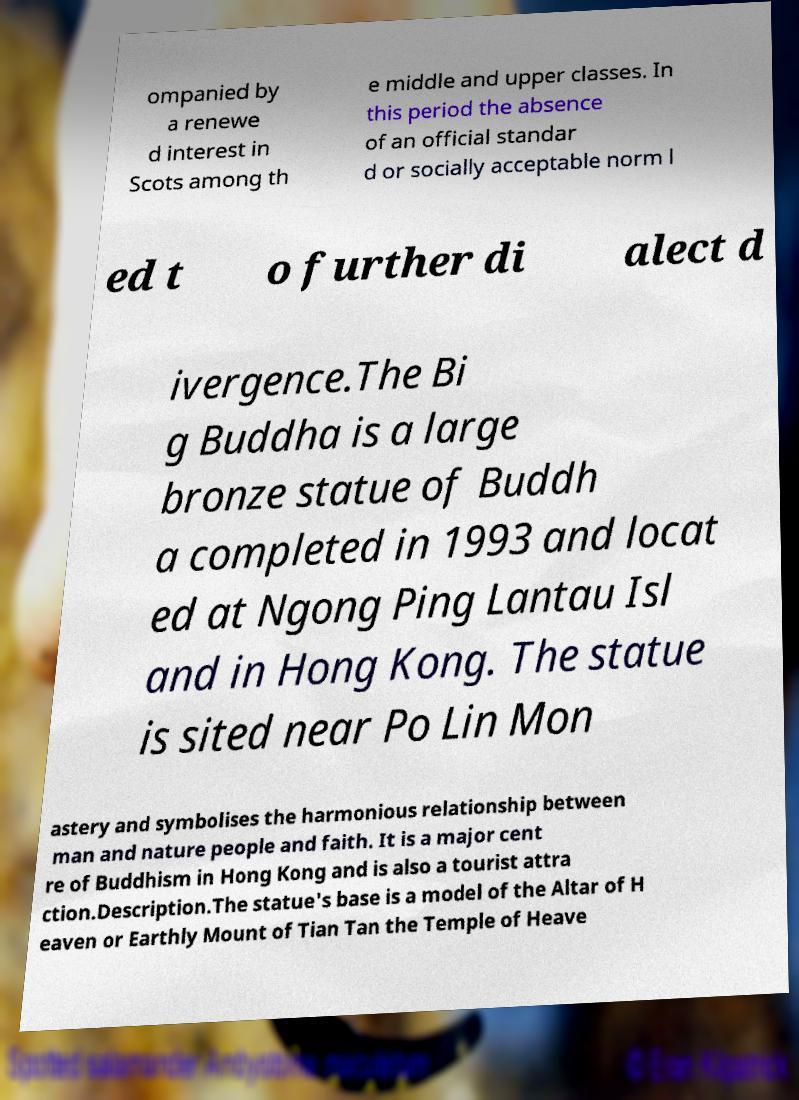Can you read and provide the text displayed in the image?This photo seems to have some interesting text. Can you extract and type it out for me? ompanied by a renewe d interest in Scots among th e middle and upper classes. In this period the absence of an official standar d or socially acceptable norm l ed t o further di alect d ivergence.The Bi g Buddha is a large bronze statue of Buddh a completed in 1993 and locat ed at Ngong Ping Lantau Isl and in Hong Kong. The statue is sited near Po Lin Mon astery and symbolises the harmonious relationship between man and nature people and faith. It is a major cent re of Buddhism in Hong Kong and is also a tourist attra ction.Description.The statue's base is a model of the Altar of H eaven or Earthly Mount of Tian Tan the Temple of Heave 